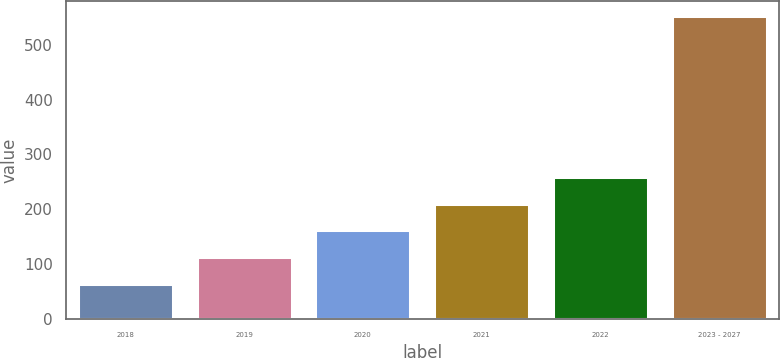Convert chart. <chart><loc_0><loc_0><loc_500><loc_500><bar_chart><fcel>2018<fcel>2019<fcel>2020<fcel>2021<fcel>2022<fcel>2023 - 2027<nl><fcel>64<fcel>112.8<fcel>161.6<fcel>210.4<fcel>259.2<fcel>552<nl></chart> 